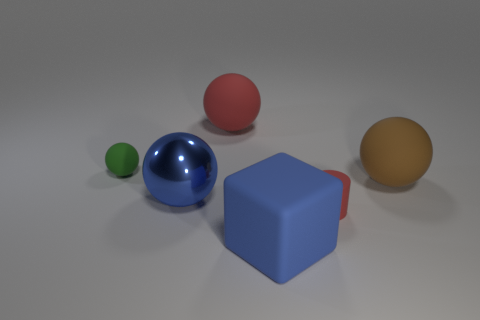Add 1 big green rubber cubes. How many objects exist? 7 Subtract all big spheres. How many spheres are left? 1 Subtract all red spheres. How many spheres are left? 3 Subtract all spheres. How many objects are left? 2 Subtract 1 blocks. How many blocks are left? 0 Subtract all red balls. How many brown cylinders are left? 0 Subtract all big red blocks. Subtract all big rubber objects. How many objects are left? 3 Add 3 blue shiny spheres. How many blue shiny spheres are left? 4 Add 3 purple matte cubes. How many purple matte cubes exist? 3 Subtract 0 yellow cylinders. How many objects are left? 6 